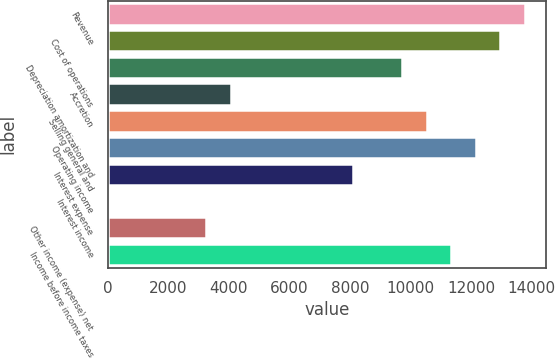Convert chart to OTSL. <chart><loc_0><loc_0><loc_500><loc_500><bar_chart><fcel>Revenue<fcel>Cost of operations<fcel>Depreciation amortization and<fcel>Accretion<fcel>Selling general and<fcel>Operating income<fcel>Interest expense<fcel>Interest income<fcel>Other income (expense) net<fcel>Income before income taxes<nl><fcel>13780.7<fcel>12970.1<fcel>9727.78<fcel>4053.65<fcel>10538.4<fcel>12159.5<fcel>8106.6<fcel>0.7<fcel>3243.06<fcel>11349<nl></chart> 